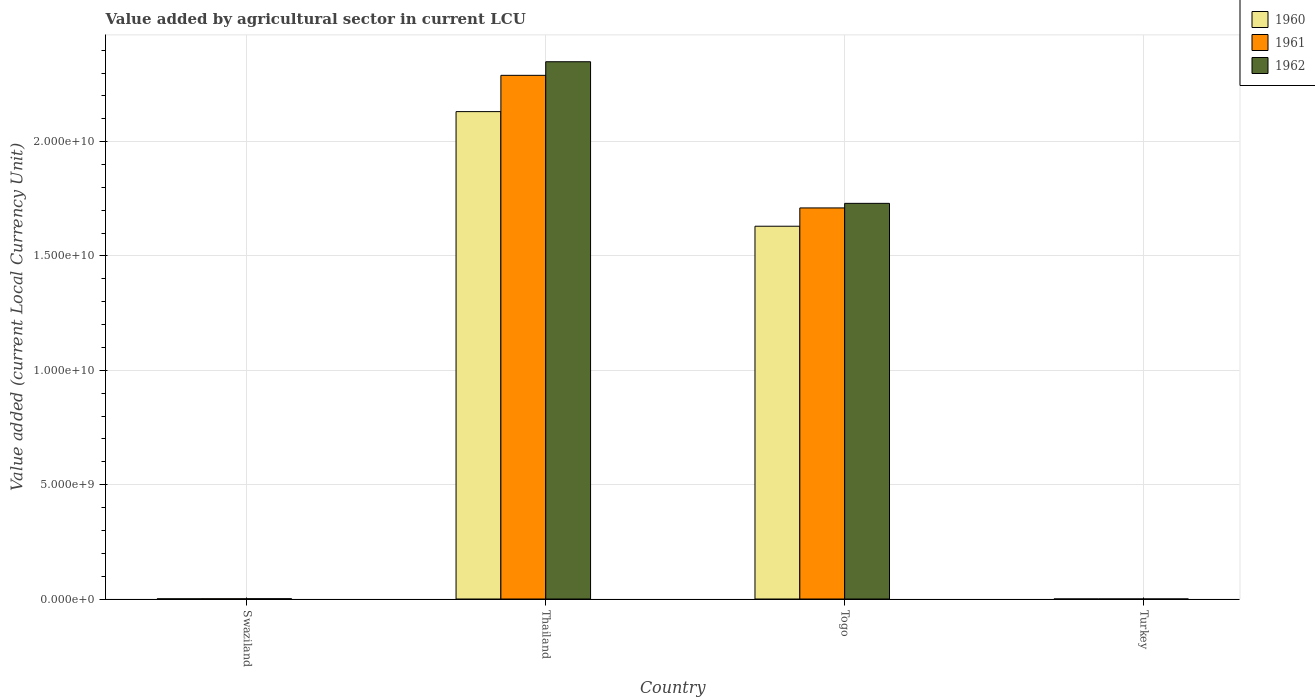How many different coloured bars are there?
Your response must be concise. 3. What is the label of the 3rd group of bars from the left?
Your response must be concise. Togo. What is the value added by agricultural sector in 1962 in Thailand?
Give a very brief answer. 2.35e+1. Across all countries, what is the maximum value added by agricultural sector in 1960?
Keep it short and to the point. 2.13e+1. Across all countries, what is the minimum value added by agricultural sector in 1960?
Offer a very short reply. 3.74e+04. In which country was the value added by agricultural sector in 1961 maximum?
Make the answer very short. Thailand. In which country was the value added by agricultural sector in 1960 minimum?
Keep it short and to the point. Turkey. What is the total value added by agricultural sector in 1961 in the graph?
Offer a very short reply. 4.00e+1. What is the difference between the value added by agricultural sector in 1962 in Swaziland and that in Togo?
Give a very brief answer. -1.73e+1. What is the difference between the value added by agricultural sector in 1961 in Turkey and the value added by agricultural sector in 1962 in Togo?
Your answer should be compact. -1.73e+1. What is the average value added by agricultural sector in 1962 per country?
Ensure brevity in your answer.  1.02e+1. What is the difference between the value added by agricultural sector of/in 1960 and value added by agricultural sector of/in 1962 in Turkey?
Offer a very short reply. -5000. What is the ratio of the value added by agricultural sector in 1962 in Togo to that in Turkey?
Your answer should be compact. 4.08e+05. Is the difference between the value added by agricultural sector in 1960 in Togo and Turkey greater than the difference between the value added by agricultural sector in 1962 in Togo and Turkey?
Offer a terse response. No. What is the difference between the highest and the second highest value added by agricultural sector in 1962?
Provide a short and direct response. 1.73e+1. What is the difference between the highest and the lowest value added by agricultural sector in 1960?
Provide a succinct answer. 2.13e+1. What does the 1st bar from the right in Thailand represents?
Your answer should be very brief. 1962. How many bars are there?
Offer a very short reply. 12. Are all the bars in the graph horizontal?
Provide a short and direct response. No. How many countries are there in the graph?
Ensure brevity in your answer.  4. Does the graph contain any zero values?
Provide a succinct answer. No. Where does the legend appear in the graph?
Your response must be concise. Top right. How are the legend labels stacked?
Offer a terse response. Vertical. What is the title of the graph?
Offer a very short reply. Value added by agricultural sector in current LCU. Does "1976" appear as one of the legend labels in the graph?
Your answer should be very brief. No. What is the label or title of the Y-axis?
Your answer should be very brief. Value added (current Local Currency Unit). What is the Value added (current Local Currency Unit) of 1960 in Swaziland?
Offer a very short reply. 7.90e+06. What is the Value added (current Local Currency Unit) of 1961 in Swaziland?
Offer a terse response. 9.30e+06. What is the Value added (current Local Currency Unit) of 1962 in Swaziland?
Provide a succinct answer. 1.14e+07. What is the Value added (current Local Currency Unit) in 1960 in Thailand?
Offer a terse response. 2.13e+1. What is the Value added (current Local Currency Unit) of 1961 in Thailand?
Your answer should be compact. 2.29e+1. What is the Value added (current Local Currency Unit) in 1962 in Thailand?
Ensure brevity in your answer.  2.35e+1. What is the Value added (current Local Currency Unit) in 1960 in Togo?
Give a very brief answer. 1.63e+1. What is the Value added (current Local Currency Unit) of 1961 in Togo?
Your answer should be compact. 1.71e+1. What is the Value added (current Local Currency Unit) of 1962 in Togo?
Your answer should be compact. 1.73e+1. What is the Value added (current Local Currency Unit) of 1960 in Turkey?
Provide a succinct answer. 3.74e+04. What is the Value added (current Local Currency Unit) in 1961 in Turkey?
Make the answer very short. 3.72e+04. What is the Value added (current Local Currency Unit) of 1962 in Turkey?
Your response must be concise. 4.24e+04. Across all countries, what is the maximum Value added (current Local Currency Unit) of 1960?
Make the answer very short. 2.13e+1. Across all countries, what is the maximum Value added (current Local Currency Unit) of 1961?
Give a very brief answer. 2.29e+1. Across all countries, what is the maximum Value added (current Local Currency Unit) of 1962?
Ensure brevity in your answer.  2.35e+1. Across all countries, what is the minimum Value added (current Local Currency Unit) in 1960?
Offer a terse response. 3.74e+04. Across all countries, what is the minimum Value added (current Local Currency Unit) in 1961?
Your answer should be very brief. 3.72e+04. Across all countries, what is the minimum Value added (current Local Currency Unit) of 1962?
Your response must be concise. 4.24e+04. What is the total Value added (current Local Currency Unit) of 1960 in the graph?
Offer a very short reply. 3.76e+1. What is the total Value added (current Local Currency Unit) in 1961 in the graph?
Make the answer very short. 4.00e+1. What is the total Value added (current Local Currency Unit) of 1962 in the graph?
Keep it short and to the point. 4.08e+1. What is the difference between the Value added (current Local Currency Unit) in 1960 in Swaziland and that in Thailand?
Your response must be concise. -2.13e+1. What is the difference between the Value added (current Local Currency Unit) of 1961 in Swaziland and that in Thailand?
Offer a terse response. -2.29e+1. What is the difference between the Value added (current Local Currency Unit) in 1962 in Swaziland and that in Thailand?
Your response must be concise. -2.35e+1. What is the difference between the Value added (current Local Currency Unit) in 1960 in Swaziland and that in Togo?
Keep it short and to the point. -1.63e+1. What is the difference between the Value added (current Local Currency Unit) in 1961 in Swaziland and that in Togo?
Offer a terse response. -1.71e+1. What is the difference between the Value added (current Local Currency Unit) of 1962 in Swaziland and that in Togo?
Offer a terse response. -1.73e+1. What is the difference between the Value added (current Local Currency Unit) in 1960 in Swaziland and that in Turkey?
Your answer should be very brief. 7.86e+06. What is the difference between the Value added (current Local Currency Unit) in 1961 in Swaziland and that in Turkey?
Your response must be concise. 9.26e+06. What is the difference between the Value added (current Local Currency Unit) in 1962 in Swaziland and that in Turkey?
Your response must be concise. 1.14e+07. What is the difference between the Value added (current Local Currency Unit) in 1960 in Thailand and that in Togo?
Make the answer very short. 5.01e+09. What is the difference between the Value added (current Local Currency Unit) in 1961 in Thailand and that in Togo?
Ensure brevity in your answer.  5.80e+09. What is the difference between the Value added (current Local Currency Unit) of 1962 in Thailand and that in Togo?
Keep it short and to the point. 6.19e+09. What is the difference between the Value added (current Local Currency Unit) of 1960 in Thailand and that in Turkey?
Keep it short and to the point. 2.13e+1. What is the difference between the Value added (current Local Currency Unit) in 1961 in Thailand and that in Turkey?
Your answer should be very brief. 2.29e+1. What is the difference between the Value added (current Local Currency Unit) of 1962 in Thailand and that in Turkey?
Your response must be concise. 2.35e+1. What is the difference between the Value added (current Local Currency Unit) of 1960 in Togo and that in Turkey?
Your response must be concise. 1.63e+1. What is the difference between the Value added (current Local Currency Unit) of 1961 in Togo and that in Turkey?
Keep it short and to the point. 1.71e+1. What is the difference between the Value added (current Local Currency Unit) of 1962 in Togo and that in Turkey?
Keep it short and to the point. 1.73e+1. What is the difference between the Value added (current Local Currency Unit) of 1960 in Swaziland and the Value added (current Local Currency Unit) of 1961 in Thailand?
Make the answer very short. -2.29e+1. What is the difference between the Value added (current Local Currency Unit) in 1960 in Swaziland and the Value added (current Local Currency Unit) in 1962 in Thailand?
Give a very brief answer. -2.35e+1. What is the difference between the Value added (current Local Currency Unit) in 1961 in Swaziland and the Value added (current Local Currency Unit) in 1962 in Thailand?
Provide a succinct answer. -2.35e+1. What is the difference between the Value added (current Local Currency Unit) in 1960 in Swaziland and the Value added (current Local Currency Unit) in 1961 in Togo?
Make the answer very short. -1.71e+1. What is the difference between the Value added (current Local Currency Unit) in 1960 in Swaziland and the Value added (current Local Currency Unit) in 1962 in Togo?
Your answer should be very brief. -1.73e+1. What is the difference between the Value added (current Local Currency Unit) in 1961 in Swaziland and the Value added (current Local Currency Unit) in 1962 in Togo?
Give a very brief answer. -1.73e+1. What is the difference between the Value added (current Local Currency Unit) in 1960 in Swaziland and the Value added (current Local Currency Unit) in 1961 in Turkey?
Your answer should be compact. 7.86e+06. What is the difference between the Value added (current Local Currency Unit) of 1960 in Swaziland and the Value added (current Local Currency Unit) of 1962 in Turkey?
Offer a terse response. 7.86e+06. What is the difference between the Value added (current Local Currency Unit) in 1961 in Swaziland and the Value added (current Local Currency Unit) in 1962 in Turkey?
Provide a succinct answer. 9.26e+06. What is the difference between the Value added (current Local Currency Unit) in 1960 in Thailand and the Value added (current Local Currency Unit) in 1961 in Togo?
Offer a terse response. 4.21e+09. What is the difference between the Value added (current Local Currency Unit) of 1960 in Thailand and the Value added (current Local Currency Unit) of 1962 in Togo?
Your answer should be very brief. 4.01e+09. What is the difference between the Value added (current Local Currency Unit) in 1961 in Thailand and the Value added (current Local Currency Unit) in 1962 in Togo?
Provide a succinct answer. 5.60e+09. What is the difference between the Value added (current Local Currency Unit) of 1960 in Thailand and the Value added (current Local Currency Unit) of 1961 in Turkey?
Offer a terse response. 2.13e+1. What is the difference between the Value added (current Local Currency Unit) in 1960 in Thailand and the Value added (current Local Currency Unit) in 1962 in Turkey?
Your answer should be compact. 2.13e+1. What is the difference between the Value added (current Local Currency Unit) of 1961 in Thailand and the Value added (current Local Currency Unit) of 1962 in Turkey?
Provide a short and direct response. 2.29e+1. What is the difference between the Value added (current Local Currency Unit) of 1960 in Togo and the Value added (current Local Currency Unit) of 1961 in Turkey?
Your answer should be compact. 1.63e+1. What is the difference between the Value added (current Local Currency Unit) in 1960 in Togo and the Value added (current Local Currency Unit) in 1962 in Turkey?
Your answer should be compact. 1.63e+1. What is the difference between the Value added (current Local Currency Unit) in 1961 in Togo and the Value added (current Local Currency Unit) in 1962 in Turkey?
Your answer should be very brief. 1.71e+1. What is the average Value added (current Local Currency Unit) of 1960 per country?
Your answer should be very brief. 9.40e+09. What is the average Value added (current Local Currency Unit) in 1961 per country?
Your answer should be very brief. 1.00e+1. What is the average Value added (current Local Currency Unit) of 1962 per country?
Give a very brief answer. 1.02e+1. What is the difference between the Value added (current Local Currency Unit) of 1960 and Value added (current Local Currency Unit) of 1961 in Swaziland?
Offer a very short reply. -1.40e+06. What is the difference between the Value added (current Local Currency Unit) in 1960 and Value added (current Local Currency Unit) in 1962 in Swaziland?
Your response must be concise. -3.50e+06. What is the difference between the Value added (current Local Currency Unit) of 1961 and Value added (current Local Currency Unit) of 1962 in Swaziland?
Your response must be concise. -2.10e+06. What is the difference between the Value added (current Local Currency Unit) in 1960 and Value added (current Local Currency Unit) in 1961 in Thailand?
Offer a very short reply. -1.59e+09. What is the difference between the Value added (current Local Currency Unit) in 1960 and Value added (current Local Currency Unit) in 1962 in Thailand?
Ensure brevity in your answer.  -2.18e+09. What is the difference between the Value added (current Local Currency Unit) in 1961 and Value added (current Local Currency Unit) in 1962 in Thailand?
Your answer should be very brief. -5.95e+08. What is the difference between the Value added (current Local Currency Unit) in 1960 and Value added (current Local Currency Unit) in 1961 in Togo?
Offer a terse response. -8.00e+08. What is the difference between the Value added (current Local Currency Unit) of 1960 and Value added (current Local Currency Unit) of 1962 in Togo?
Offer a terse response. -1.00e+09. What is the difference between the Value added (current Local Currency Unit) in 1961 and Value added (current Local Currency Unit) in 1962 in Togo?
Ensure brevity in your answer.  -2.00e+08. What is the difference between the Value added (current Local Currency Unit) in 1960 and Value added (current Local Currency Unit) in 1962 in Turkey?
Give a very brief answer. -5000. What is the difference between the Value added (current Local Currency Unit) of 1961 and Value added (current Local Currency Unit) of 1962 in Turkey?
Make the answer very short. -5200. What is the ratio of the Value added (current Local Currency Unit) in 1962 in Swaziland to that in Togo?
Make the answer very short. 0. What is the ratio of the Value added (current Local Currency Unit) in 1960 in Swaziland to that in Turkey?
Ensure brevity in your answer.  211.23. What is the ratio of the Value added (current Local Currency Unit) of 1961 in Swaziland to that in Turkey?
Your answer should be very brief. 250. What is the ratio of the Value added (current Local Currency Unit) in 1962 in Swaziland to that in Turkey?
Provide a short and direct response. 268.87. What is the ratio of the Value added (current Local Currency Unit) of 1960 in Thailand to that in Togo?
Ensure brevity in your answer.  1.31. What is the ratio of the Value added (current Local Currency Unit) of 1961 in Thailand to that in Togo?
Offer a terse response. 1.34. What is the ratio of the Value added (current Local Currency Unit) in 1962 in Thailand to that in Togo?
Offer a very short reply. 1.36. What is the ratio of the Value added (current Local Currency Unit) of 1960 in Thailand to that in Turkey?
Provide a succinct answer. 5.70e+05. What is the ratio of the Value added (current Local Currency Unit) in 1961 in Thailand to that in Turkey?
Keep it short and to the point. 6.16e+05. What is the ratio of the Value added (current Local Currency Unit) in 1962 in Thailand to that in Turkey?
Give a very brief answer. 5.54e+05. What is the ratio of the Value added (current Local Currency Unit) in 1960 in Togo to that in Turkey?
Make the answer very short. 4.36e+05. What is the ratio of the Value added (current Local Currency Unit) of 1961 in Togo to that in Turkey?
Your answer should be very brief. 4.60e+05. What is the ratio of the Value added (current Local Currency Unit) in 1962 in Togo to that in Turkey?
Give a very brief answer. 4.08e+05. What is the difference between the highest and the second highest Value added (current Local Currency Unit) of 1960?
Keep it short and to the point. 5.01e+09. What is the difference between the highest and the second highest Value added (current Local Currency Unit) of 1961?
Ensure brevity in your answer.  5.80e+09. What is the difference between the highest and the second highest Value added (current Local Currency Unit) in 1962?
Make the answer very short. 6.19e+09. What is the difference between the highest and the lowest Value added (current Local Currency Unit) of 1960?
Provide a succinct answer. 2.13e+1. What is the difference between the highest and the lowest Value added (current Local Currency Unit) of 1961?
Your answer should be compact. 2.29e+1. What is the difference between the highest and the lowest Value added (current Local Currency Unit) in 1962?
Your answer should be compact. 2.35e+1. 